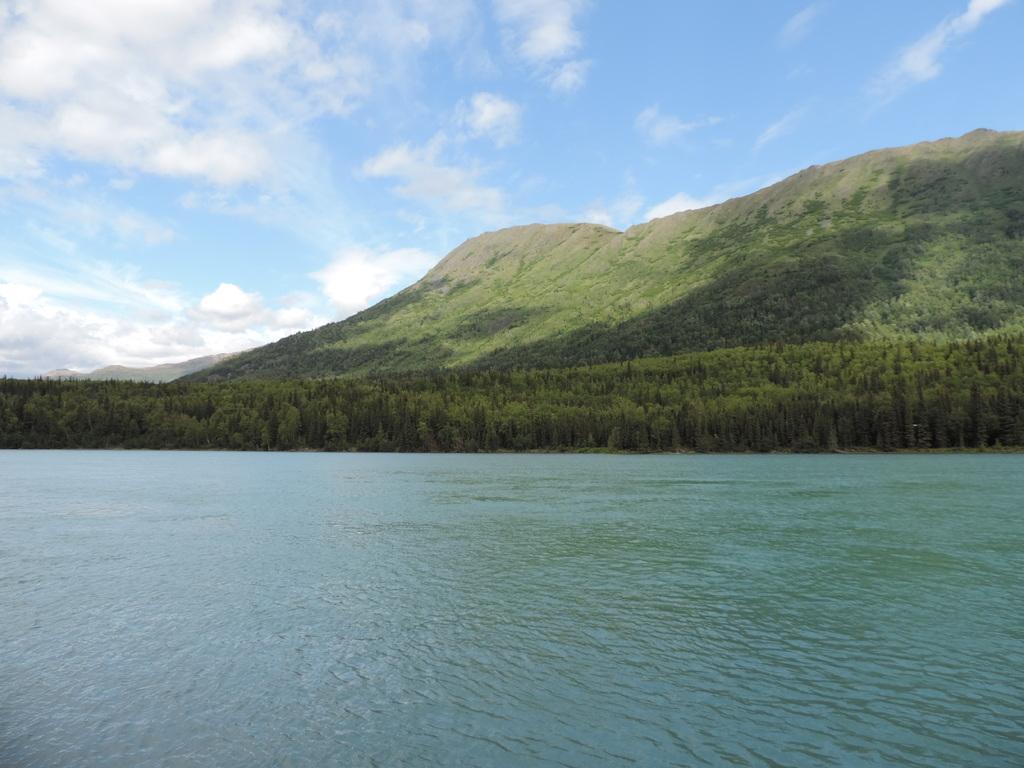In one or two sentences, can you explain what this image depicts? At the bottom of the image there is water. Behind the water there are trees and also there is a hill with trees. At the top of the image there is a sky with clouds. 